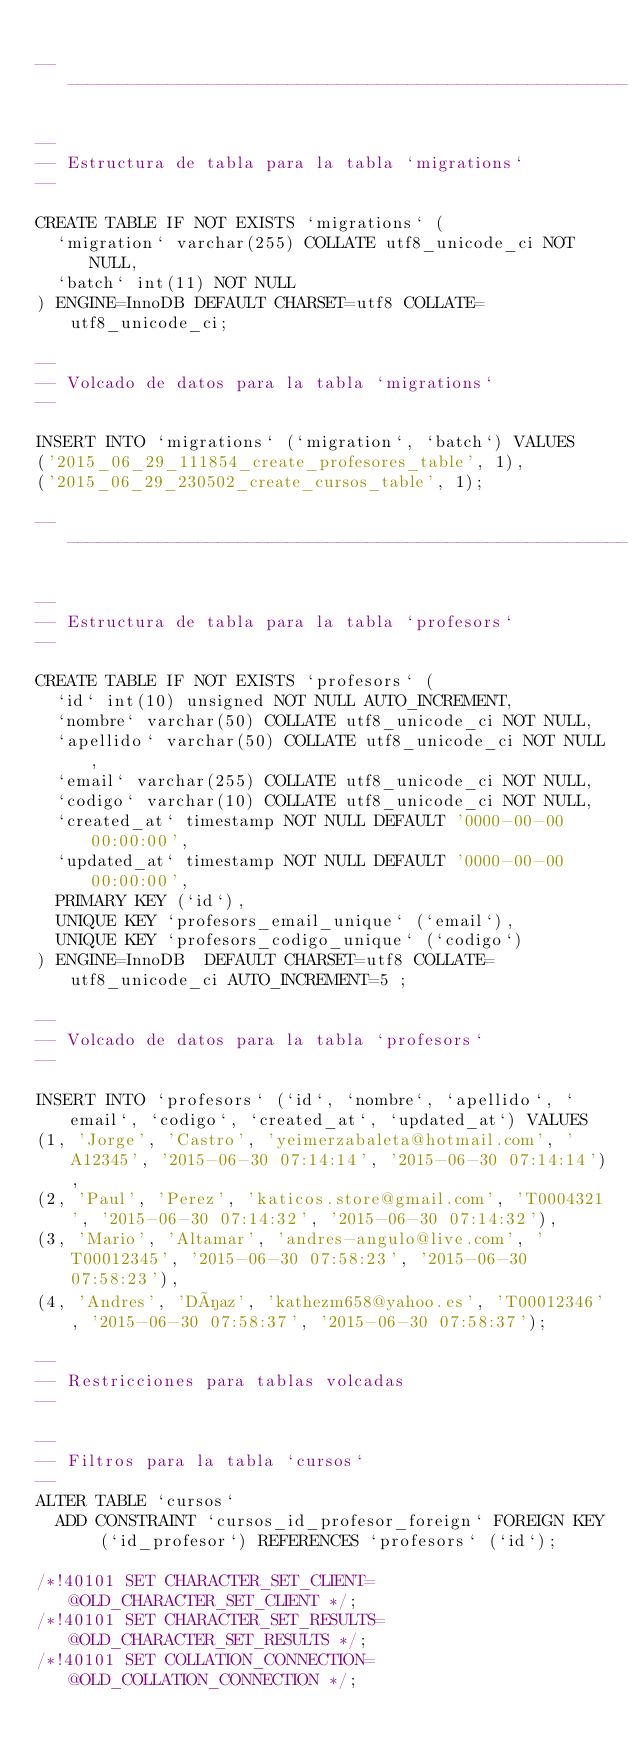Convert code to text. <code><loc_0><loc_0><loc_500><loc_500><_SQL_>
-- --------------------------------------------------------

--
-- Estructura de tabla para la tabla `migrations`
--

CREATE TABLE IF NOT EXISTS `migrations` (
  `migration` varchar(255) COLLATE utf8_unicode_ci NOT NULL,
  `batch` int(11) NOT NULL
) ENGINE=InnoDB DEFAULT CHARSET=utf8 COLLATE=utf8_unicode_ci;

--
-- Volcado de datos para la tabla `migrations`
--

INSERT INTO `migrations` (`migration`, `batch`) VALUES
('2015_06_29_111854_create_profesores_table', 1),
('2015_06_29_230502_create_cursos_table', 1);

-- --------------------------------------------------------

--
-- Estructura de tabla para la tabla `profesors`
--

CREATE TABLE IF NOT EXISTS `profesors` (
  `id` int(10) unsigned NOT NULL AUTO_INCREMENT,
  `nombre` varchar(50) COLLATE utf8_unicode_ci NOT NULL,
  `apellido` varchar(50) COLLATE utf8_unicode_ci NOT NULL,
  `email` varchar(255) COLLATE utf8_unicode_ci NOT NULL,
  `codigo` varchar(10) COLLATE utf8_unicode_ci NOT NULL,
  `created_at` timestamp NOT NULL DEFAULT '0000-00-00 00:00:00',
  `updated_at` timestamp NOT NULL DEFAULT '0000-00-00 00:00:00',
  PRIMARY KEY (`id`),
  UNIQUE KEY `profesors_email_unique` (`email`),
  UNIQUE KEY `profesors_codigo_unique` (`codigo`)
) ENGINE=InnoDB  DEFAULT CHARSET=utf8 COLLATE=utf8_unicode_ci AUTO_INCREMENT=5 ;

--
-- Volcado de datos para la tabla `profesors`
--

INSERT INTO `profesors` (`id`, `nombre`, `apellido`, `email`, `codigo`, `created_at`, `updated_at`) VALUES
(1, 'Jorge', 'Castro', 'yeimerzabaleta@hotmail.com', 'A12345', '2015-06-30 07:14:14', '2015-06-30 07:14:14'),
(2, 'Paul', 'Perez', 'katicos.store@gmail.com', 'T0004321', '2015-06-30 07:14:32', '2015-06-30 07:14:32'),
(3, 'Mario', 'Altamar', 'andres-angulo@live.com', 'T00012345', '2015-06-30 07:58:23', '2015-06-30 07:58:23'),
(4, 'Andres', 'Díaz', 'kathezm658@yahoo.es', 'T00012346', '2015-06-30 07:58:37', '2015-06-30 07:58:37');

--
-- Restricciones para tablas volcadas
--

--
-- Filtros para la tabla `cursos`
--
ALTER TABLE `cursos`
  ADD CONSTRAINT `cursos_id_profesor_foreign` FOREIGN KEY (`id_profesor`) REFERENCES `profesors` (`id`);

/*!40101 SET CHARACTER_SET_CLIENT=@OLD_CHARACTER_SET_CLIENT */;
/*!40101 SET CHARACTER_SET_RESULTS=@OLD_CHARACTER_SET_RESULTS */;
/*!40101 SET COLLATION_CONNECTION=@OLD_COLLATION_CONNECTION */;
</code> 